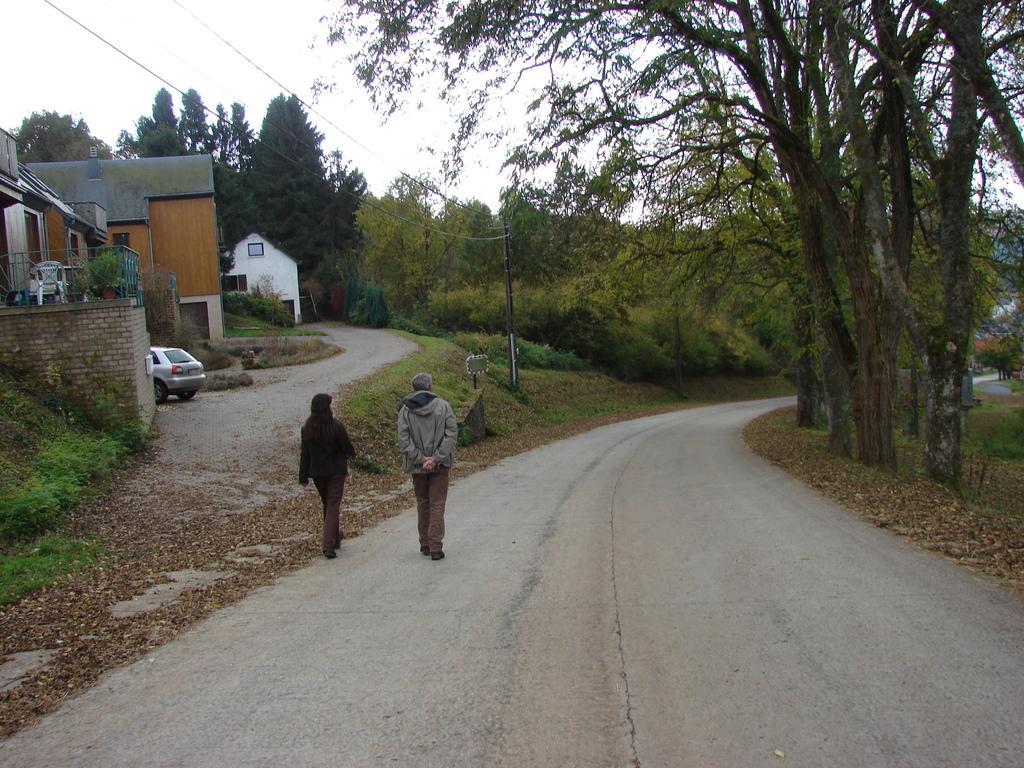Describe this image in one or two sentences. In this picture we can observe two members walking on this road. One of them was woman wearing a black color dress. On the left side there is a house. We can observe a car parked here. There is some grass on the land. We can observe some plants and trees. In the background there is a sky. 